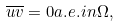Convert formula to latex. <formula><loc_0><loc_0><loc_500><loc_500>\overline { u } \overline { v } = 0 a . e . i n \Omega ,</formula> 